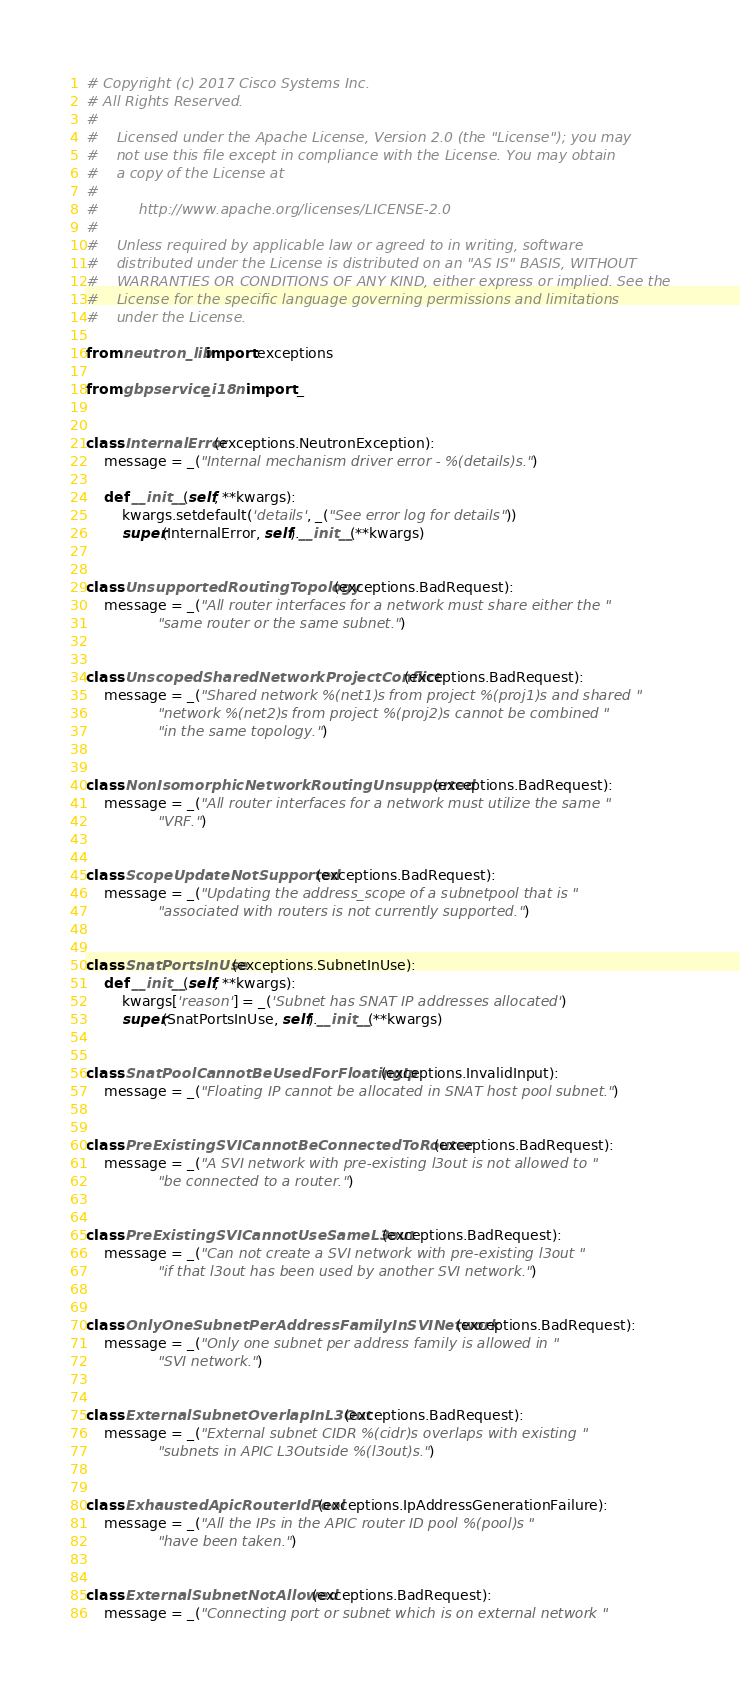Convert code to text. <code><loc_0><loc_0><loc_500><loc_500><_Python_># Copyright (c) 2017 Cisco Systems Inc.
# All Rights Reserved.
#
#    Licensed under the Apache License, Version 2.0 (the "License"); you may
#    not use this file except in compliance with the License. You may obtain
#    a copy of the License at
#
#         http://www.apache.org/licenses/LICENSE-2.0
#
#    Unless required by applicable law or agreed to in writing, software
#    distributed under the License is distributed on an "AS IS" BASIS, WITHOUT
#    WARRANTIES OR CONDITIONS OF ANY KIND, either express or implied. See the
#    License for the specific language governing permissions and limitations
#    under the License.

from neutron_lib import exceptions

from gbpservice._i18n import _


class InternalError(exceptions.NeutronException):
    message = _("Internal mechanism driver error - %(details)s.")

    def __init__(self, **kwargs):
        kwargs.setdefault('details', _("See error log for details"))
        super(InternalError, self).__init__(**kwargs)


class UnsupportedRoutingTopology(exceptions.BadRequest):
    message = _("All router interfaces for a network must share either the "
                "same router or the same subnet.")


class UnscopedSharedNetworkProjectConflict(exceptions.BadRequest):
    message = _("Shared network %(net1)s from project %(proj1)s and shared "
                "network %(net2)s from project %(proj2)s cannot be combined "
                "in the same topology.")


class NonIsomorphicNetworkRoutingUnsupported(exceptions.BadRequest):
    message = _("All router interfaces for a network must utilize the same "
                "VRF.")


class ScopeUpdateNotSupported(exceptions.BadRequest):
    message = _("Updating the address_scope of a subnetpool that is "
                "associated with routers is not currently supported.")


class SnatPortsInUse(exceptions.SubnetInUse):
    def __init__(self, **kwargs):
        kwargs['reason'] = _('Subnet has SNAT IP addresses allocated')
        super(SnatPortsInUse, self).__init__(**kwargs)


class SnatPoolCannotBeUsedForFloatingIp(exceptions.InvalidInput):
    message = _("Floating IP cannot be allocated in SNAT host pool subnet.")


class PreExistingSVICannotBeConnectedToRouter(exceptions.BadRequest):
    message = _("A SVI network with pre-existing l3out is not allowed to "
                "be connected to a router.")


class PreExistingSVICannotUseSameL3out(exceptions.BadRequest):
    message = _("Can not create a SVI network with pre-existing l3out "
                "if that l3out has been used by another SVI network.")


class OnlyOneSubnetPerAddressFamilyInSVINetwork(exceptions.BadRequest):
    message = _("Only one subnet per address family is allowed in "
                "SVI network.")


class ExternalSubnetOverlapInL3Out(exceptions.BadRequest):
    message = _("External subnet CIDR %(cidr)s overlaps with existing "
                "subnets in APIC L3Outside %(l3out)s.")


class ExhaustedApicRouterIdPool(exceptions.IpAddressGenerationFailure):
    message = _("All the IPs in the APIC router ID pool %(pool)s "
                "have been taken.")


class ExternalSubnetNotAllowed(exceptions.BadRequest):
    message = _("Connecting port or subnet which is on external network "</code> 